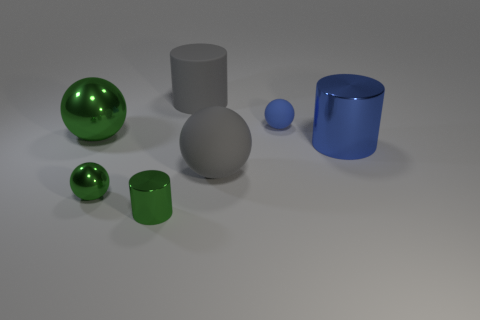Which objects in the image could be used to contain water? The blue cylindrical container could hold water. Additionally, depending on its solidity, the open-ended cylinder might potentially hold water if its bottom is sealed. 